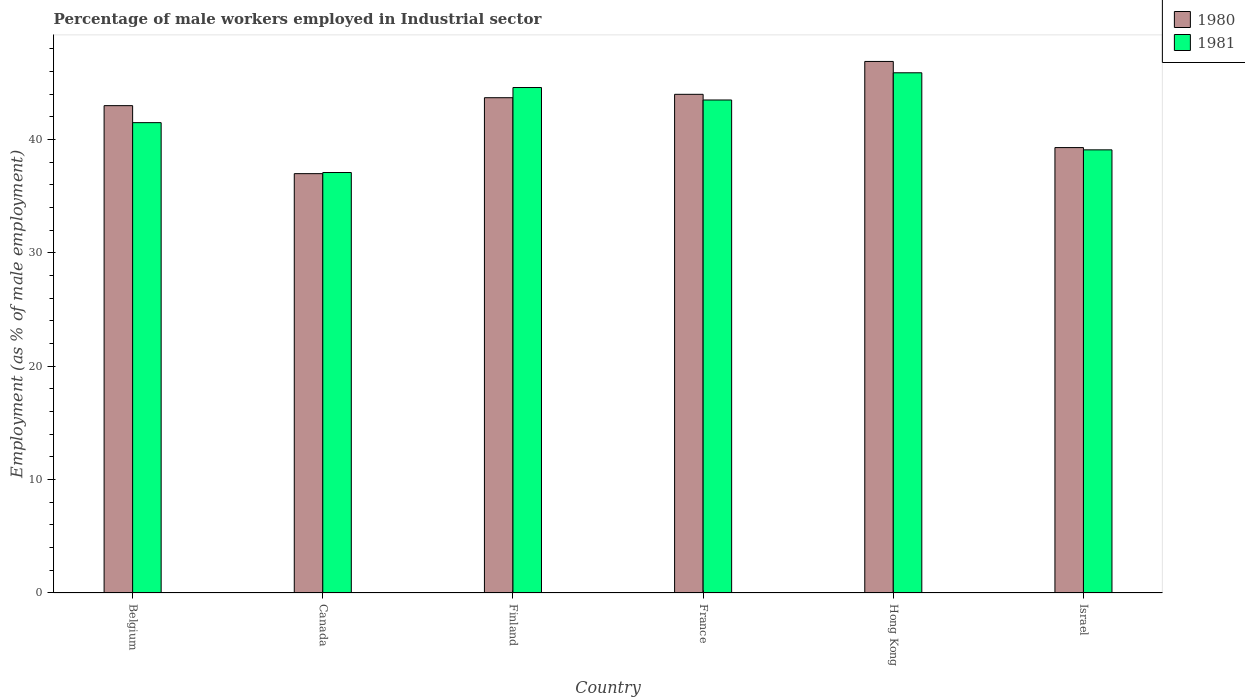How many different coloured bars are there?
Your answer should be very brief. 2. Are the number of bars per tick equal to the number of legend labels?
Give a very brief answer. Yes. How many bars are there on the 5th tick from the right?
Make the answer very short. 2. What is the percentage of male workers employed in Industrial sector in 1981 in Israel?
Keep it short and to the point. 39.1. Across all countries, what is the maximum percentage of male workers employed in Industrial sector in 1980?
Offer a very short reply. 46.9. Across all countries, what is the minimum percentage of male workers employed in Industrial sector in 1981?
Provide a succinct answer. 37.1. In which country was the percentage of male workers employed in Industrial sector in 1980 maximum?
Keep it short and to the point. Hong Kong. In which country was the percentage of male workers employed in Industrial sector in 1980 minimum?
Provide a short and direct response. Canada. What is the total percentage of male workers employed in Industrial sector in 1981 in the graph?
Provide a succinct answer. 251.7. What is the difference between the percentage of male workers employed in Industrial sector in 1980 in France and that in Hong Kong?
Keep it short and to the point. -2.9. What is the difference between the percentage of male workers employed in Industrial sector in 1980 in Hong Kong and the percentage of male workers employed in Industrial sector in 1981 in Belgium?
Make the answer very short. 5.4. What is the average percentage of male workers employed in Industrial sector in 1981 per country?
Offer a very short reply. 41.95. What is the difference between the percentage of male workers employed in Industrial sector of/in 1980 and percentage of male workers employed in Industrial sector of/in 1981 in Israel?
Give a very brief answer. 0.2. What is the ratio of the percentage of male workers employed in Industrial sector in 1980 in Canada to that in Israel?
Your response must be concise. 0.94. Is the percentage of male workers employed in Industrial sector in 1981 in France less than that in Hong Kong?
Give a very brief answer. Yes. What is the difference between the highest and the second highest percentage of male workers employed in Industrial sector in 1981?
Give a very brief answer. -1.1. What is the difference between the highest and the lowest percentage of male workers employed in Industrial sector in 1980?
Your response must be concise. 9.9. In how many countries, is the percentage of male workers employed in Industrial sector in 1980 greater than the average percentage of male workers employed in Industrial sector in 1980 taken over all countries?
Give a very brief answer. 4. Is the sum of the percentage of male workers employed in Industrial sector in 1980 in Canada and Israel greater than the maximum percentage of male workers employed in Industrial sector in 1981 across all countries?
Provide a short and direct response. Yes. How many bars are there?
Provide a short and direct response. 12. Are the values on the major ticks of Y-axis written in scientific E-notation?
Offer a terse response. No. Does the graph contain any zero values?
Offer a very short reply. No. What is the title of the graph?
Offer a terse response. Percentage of male workers employed in Industrial sector. What is the label or title of the X-axis?
Keep it short and to the point. Country. What is the label or title of the Y-axis?
Offer a terse response. Employment (as % of male employment). What is the Employment (as % of male employment) in 1981 in Belgium?
Give a very brief answer. 41.5. What is the Employment (as % of male employment) of 1980 in Canada?
Provide a succinct answer. 37. What is the Employment (as % of male employment) in 1981 in Canada?
Your answer should be compact. 37.1. What is the Employment (as % of male employment) of 1980 in Finland?
Your answer should be compact. 43.7. What is the Employment (as % of male employment) of 1981 in Finland?
Provide a short and direct response. 44.6. What is the Employment (as % of male employment) in 1980 in France?
Offer a terse response. 44. What is the Employment (as % of male employment) in 1981 in France?
Give a very brief answer. 43.5. What is the Employment (as % of male employment) in 1980 in Hong Kong?
Keep it short and to the point. 46.9. What is the Employment (as % of male employment) in 1981 in Hong Kong?
Offer a terse response. 45.9. What is the Employment (as % of male employment) of 1980 in Israel?
Give a very brief answer. 39.3. What is the Employment (as % of male employment) of 1981 in Israel?
Give a very brief answer. 39.1. Across all countries, what is the maximum Employment (as % of male employment) in 1980?
Offer a terse response. 46.9. Across all countries, what is the maximum Employment (as % of male employment) of 1981?
Provide a short and direct response. 45.9. Across all countries, what is the minimum Employment (as % of male employment) of 1980?
Offer a very short reply. 37. Across all countries, what is the minimum Employment (as % of male employment) in 1981?
Offer a very short reply. 37.1. What is the total Employment (as % of male employment) of 1980 in the graph?
Provide a short and direct response. 253.9. What is the total Employment (as % of male employment) in 1981 in the graph?
Offer a terse response. 251.7. What is the difference between the Employment (as % of male employment) of 1980 in Belgium and that in Canada?
Make the answer very short. 6. What is the difference between the Employment (as % of male employment) in 1980 in Belgium and that in Finland?
Your response must be concise. -0.7. What is the difference between the Employment (as % of male employment) of 1981 in Belgium and that in Finland?
Ensure brevity in your answer.  -3.1. What is the difference between the Employment (as % of male employment) in 1980 in Belgium and that in Israel?
Provide a short and direct response. 3.7. What is the difference between the Employment (as % of male employment) of 1981 in Belgium and that in Israel?
Your answer should be compact. 2.4. What is the difference between the Employment (as % of male employment) of 1980 in Canada and that in France?
Give a very brief answer. -7. What is the difference between the Employment (as % of male employment) in 1980 in Canada and that in Hong Kong?
Keep it short and to the point. -9.9. What is the difference between the Employment (as % of male employment) of 1981 in Canada and that in Hong Kong?
Give a very brief answer. -8.8. What is the difference between the Employment (as % of male employment) in 1980 in Canada and that in Israel?
Ensure brevity in your answer.  -2.3. What is the difference between the Employment (as % of male employment) of 1980 in Finland and that in France?
Offer a very short reply. -0.3. What is the difference between the Employment (as % of male employment) in 1981 in Finland and that in Hong Kong?
Your answer should be very brief. -1.3. What is the difference between the Employment (as % of male employment) in 1980 in Finland and that in Israel?
Offer a very short reply. 4.4. What is the difference between the Employment (as % of male employment) of 1981 in Finland and that in Israel?
Your response must be concise. 5.5. What is the difference between the Employment (as % of male employment) in 1981 in France and that in Hong Kong?
Provide a short and direct response. -2.4. What is the difference between the Employment (as % of male employment) in 1981 in France and that in Israel?
Offer a very short reply. 4.4. What is the difference between the Employment (as % of male employment) of 1980 in Hong Kong and that in Israel?
Give a very brief answer. 7.6. What is the difference between the Employment (as % of male employment) of 1980 in Belgium and the Employment (as % of male employment) of 1981 in Canada?
Give a very brief answer. 5.9. What is the difference between the Employment (as % of male employment) in 1980 in Belgium and the Employment (as % of male employment) in 1981 in France?
Your response must be concise. -0.5. What is the difference between the Employment (as % of male employment) in 1980 in Belgium and the Employment (as % of male employment) in 1981 in Israel?
Ensure brevity in your answer.  3.9. What is the difference between the Employment (as % of male employment) of 1980 in Finland and the Employment (as % of male employment) of 1981 in France?
Give a very brief answer. 0.2. What is the difference between the Employment (as % of male employment) of 1980 in Finland and the Employment (as % of male employment) of 1981 in Israel?
Ensure brevity in your answer.  4.6. What is the difference between the Employment (as % of male employment) of 1980 in France and the Employment (as % of male employment) of 1981 in Hong Kong?
Offer a very short reply. -1.9. What is the difference between the Employment (as % of male employment) in 1980 in Hong Kong and the Employment (as % of male employment) in 1981 in Israel?
Offer a very short reply. 7.8. What is the average Employment (as % of male employment) of 1980 per country?
Offer a terse response. 42.32. What is the average Employment (as % of male employment) of 1981 per country?
Your answer should be very brief. 41.95. What is the difference between the Employment (as % of male employment) in 1980 and Employment (as % of male employment) in 1981 in France?
Your answer should be compact. 0.5. What is the difference between the Employment (as % of male employment) in 1980 and Employment (as % of male employment) in 1981 in Hong Kong?
Your answer should be compact. 1. What is the difference between the Employment (as % of male employment) in 1980 and Employment (as % of male employment) in 1981 in Israel?
Offer a terse response. 0.2. What is the ratio of the Employment (as % of male employment) of 1980 in Belgium to that in Canada?
Give a very brief answer. 1.16. What is the ratio of the Employment (as % of male employment) of 1981 in Belgium to that in Canada?
Provide a succinct answer. 1.12. What is the ratio of the Employment (as % of male employment) of 1980 in Belgium to that in Finland?
Give a very brief answer. 0.98. What is the ratio of the Employment (as % of male employment) of 1981 in Belgium to that in Finland?
Your answer should be very brief. 0.93. What is the ratio of the Employment (as % of male employment) in 1980 in Belgium to that in France?
Your response must be concise. 0.98. What is the ratio of the Employment (as % of male employment) in 1981 in Belgium to that in France?
Your answer should be compact. 0.95. What is the ratio of the Employment (as % of male employment) in 1980 in Belgium to that in Hong Kong?
Your answer should be very brief. 0.92. What is the ratio of the Employment (as % of male employment) in 1981 in Belgium to that in Hong Kong?
Give a very brief answer. 0.9. What is the ratio of the Employment (as % of male employment) of 1980 in Belgium to that in Israel?
Give a very brief answer. 1.09. What is the ratio of the Employment (as % of male employment) in 1981 in Belgium to that in Israel?
Offer a terse response. 1.06. What is the ratio of the Employment (as % of male employment) in 1980 in Canada to that in Finland?
Make the answer very short. 0.85. What is the ratio of the Employment (as % of male employment) in 1981 in Canada to that in Finland?
Provide a succinct answer. 0.83. What is the ratio of the Employment (as % of male employment) in 1980 in Canada to that in France?
Make the answer very short. 0.84. What is the ratio of the Employment (as % of male employment) in 1981 in Canada to that in France?
Give a very brief answer. 0.85. What is the ratio of the Employment (as % of male employment) in 1980 in Canada to that in Hong Kong?
Offer a very short reply. 0.79. What is the ratio of the Employment (as % of male employment) of 1981 in Canada to that in Hong Kong?
Give a very brief answer. 0.81. What is the ratio of the Employment (as % of male employment) in 1980 in Canada to that in Israel?
Your response must be concise. 0.94. What is the ratio of the Employment (as % of male employment) in 1981 in Canada to that in Israel?
Provide a succinct answer. 0.95. What is the ratio of the Employment (as % of male employment) in 1980 in Finland to that in France?
Make the answer very short. 0.99. What is the ratio of the Employment (as % of male employment) of 1981 in Finland to that in France?
Your response must be concise. 1.03. What is the ratio of the Employment (as % of male employment) of 1980 in Finland to that in Hong Kong?
Offer a very short reply. 0.93. What is the ratio of the Employment (as % of male employment) in 1981 in Finland to that in Hong Kong?
Provide a short and direct response. 0.97. What is the ratio of the Employment (as % of male employment) of 1980 in Finland to that in Israel?
Ensure brevity in your answer.  1.11. What is the ratio of the Employment (as % of male employment) of 1981 in Finland to that in Israel?
Keep it short and to the point. 1.14. What is the ratio of the Employment (as % of male employment) of 1980 in France to that in Hong Kong?
Offer a terse response. 0.94. What is the ratio of the Employment (as % of male employment) of 1981 in France to that in Hong Kong?
Make the answer very short. 0.95. What is the ratio of the Employment (as % of male employment) of 1980 in France to that in Israel?
Keep it short and to the point. 1.12. What is the ratio of the Employment (as % of male employment) in 1981 in France to that in Israel?
Your answer should be very brief. 1.11. What is the ratio of the Employment (as % of male employment) in 1980 in Hong Kong to that in Israel?
Give a very brief answer. 1.19. What is the ratio of the Employment (as % of male employment) of 1981 in Hong Kong to that in Israel?
Provide a short and direct response. 1.17. What is the difference between the highest and the lowest Employment (as % of male employment) of 1980?
Offer a very short reply. 9.9. What is the difference between the highest and the lowest Employment (as % of male employment) in 1981?
Your answer should be compact. 8.8. 